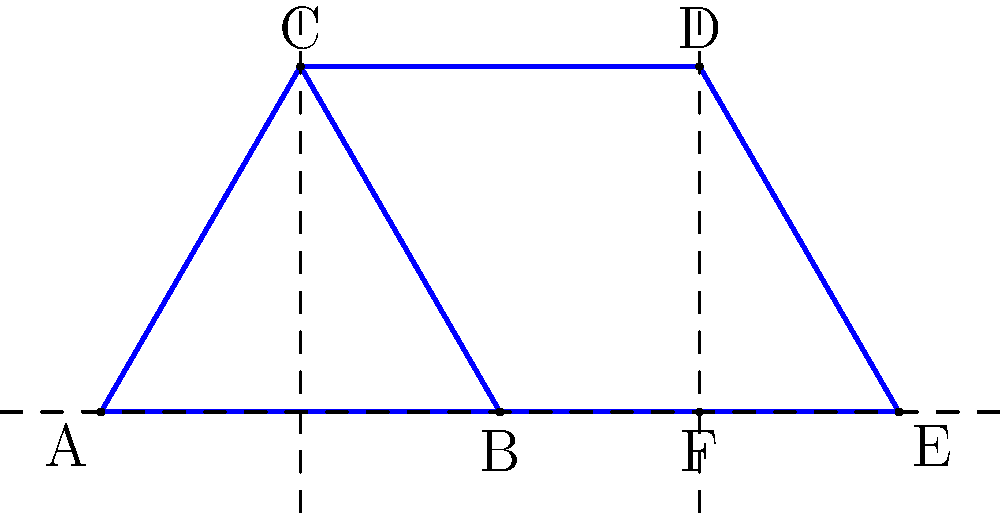In the 2D crystal lattice shown above, which symmetry elements are present? Consider rotational symmetry and mirror planes. To identify the symmetry elements in this 2D crystal lattice, we need to analyze the pattern for rotational symmetry and mirror planes:

1. Rotational symmetry:
   - Observe that the pattern repeats when rotated 60° around any lattice point (e.g., B or F).
   - This indicates a 6-fold rotational symmetry (360°/60° = 6).

2. Mirror planes:
   a) Vertical mirror planes:
      - There are vertical lines of symmetry passing through points B and F.
      - These are represented by the vertical dashed lines in the diagram.
   
   b) Horizontal mirror plane:
      - There is a horizontal line of symmetry along the base of the triangles (line BE).
      - This is represented by the horizontal dashed line in the diagram.
   
   c) Diagonal mirror planes:
      - There are also diagonal lines of symmetry passing through the vertices of the triangles (e.g., AC and CE).
      - These are not explicitly shown in the diagram but can be inferred from the pattern.

In crystallography, this pattern corresponds to the hexagonal crystal system, specifically the p6m plane group (using Hermann–Mauguin notation).

The symmetry elements present are:
- 6-fold rotational symmetry
- 3 sets of mirror planes (vertical, horizontal, and diagonal)
Answer: 6-fold rotation, 3 sets of mirror planes 